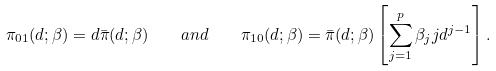<formula> <loc_0><loc_0><loc_500><loc_500>\pi _ { 0 1 } ( d ; \beta ) = d \bar { \pi } ( d ; \beta ) \quad a n d \quad \pi _ { 1 0 } ( d ; \beta ) = \bar { \pi } ( d ; \beta ) \left [ \sum _ { j = 1 } ^ { p } \beta _ { j } j d ^ { j - 1 } \right ] .</formula> 